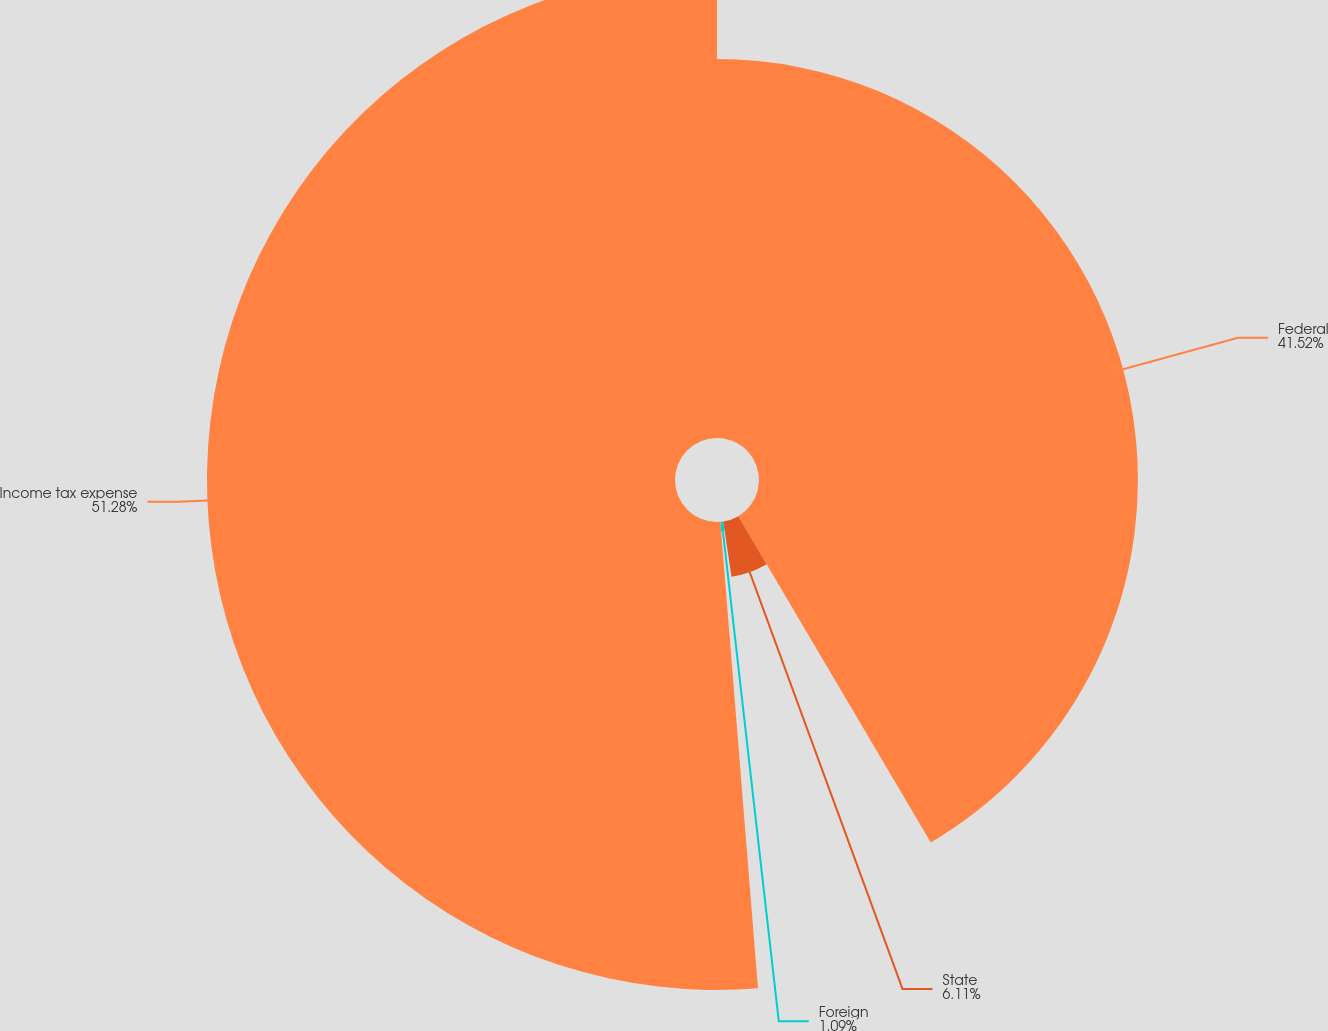<chart> <loc_0><loc_0><loc_500><loc_500><pie_chart><fcel>Federal<fcel>State<fcel>Foreign<fcel>Income tax expense<nl><fcel>41.52%<fcel>6.11%<fcel>1.09%<fcel>51.28%<nl></chart> 